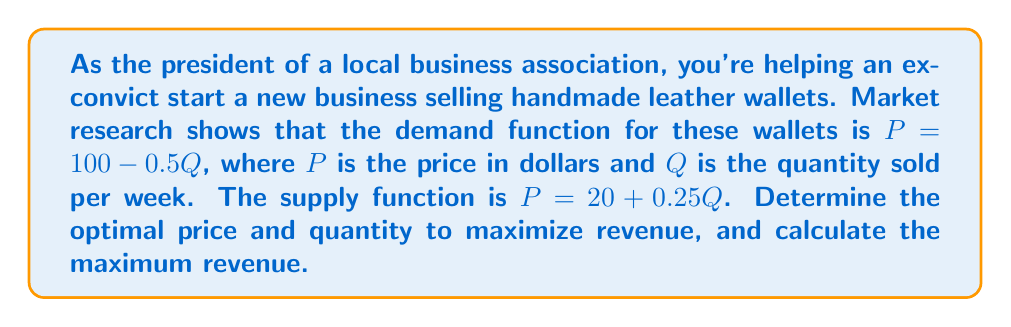Help me with this question. To solve this problem, we'll follow these steps:

1) Find the equilibrium price and quantity:
   At equilibrium, supply equals demand:
   $100 - 0.5Q = 20 + 0.25Q$
   $80 = 0.75Q$
   $Q = 106.67$

   Substituting this into either equation:
   $P = 100 - 0.5(106.67) = 46.67$

2) To maximize revenue, we need to find the point where marginal revenue equals marginal cost:
   Revenue function: $R = PQ = (100 - 0.5Q)Q = 100Q - 0.5Q^2$
   Marginal Revenue: $MR = \frac{dR}{dQ} = 100 - Q$

   Marginal Cost is the supply function: $MC = 20 + 0.25Q$

3) Set MR = MC:
   $100 - Q = 20 + 0.25Q$
   $80 = 1.25Q$
   $Q = 64$

4) Find the optimal price by substituting Q into the demand function:
   $P = 100 - 0.5(64) = 68$

5) Calculate the maximum revenue:
   $R = PQ = 68 * 64 = 4,352$

Therefore, the optimal price is $68, the optimal quantity is 64 units per week, and the maximum revenue is $4,352 per week.
Answer: Price: $68, Quantity: 64, Revenue: $4,352 